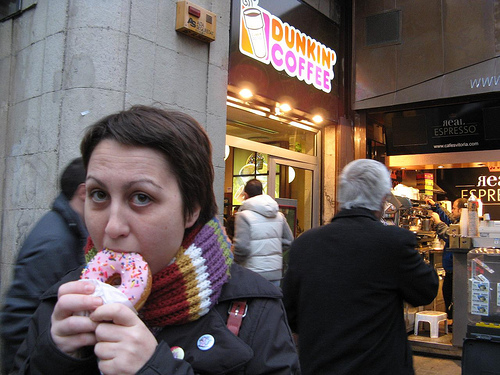Extract all visible text content from this image. DUNKIN COFFEE ESPRESSO neaL ESPRESSO Re 